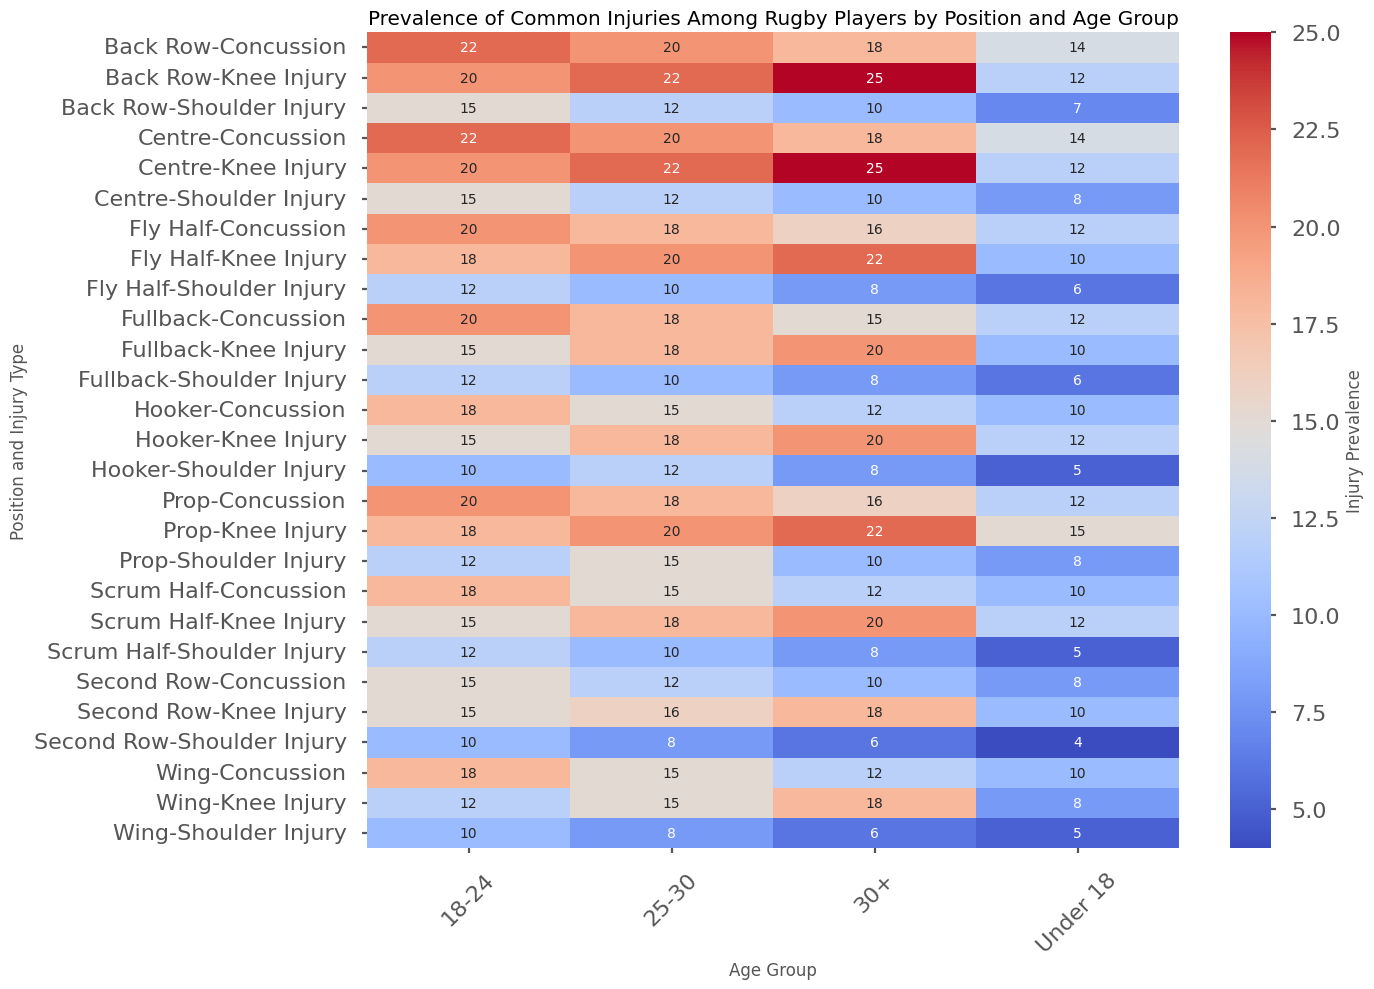What is the prevalence of knee injuries among Back Rows aged 30+? Look for the prevalence value of knee injuries for the Back Row position in the 30+ age group in the heatmap.
Answer: 25 Which age group has the highest prevalence of shoulder injuries among Fly Halfs? Compare the prevalence values of shoulder injuries for the Fly Half position across all age groups in the heatmap.
Answer: 18-24 How many total concussions are reported for Hookers across all age groups? Sum the prevalence values of concussions for the Hooker position across all age groups: 10 (Under 18) + 18 (18-24) + 15 (25-30) + 12 (30+).
Answer: 55 Is the prevalence of knee injuries higher among Scrum Halfs or Centres aged 25-30? Compare the prevalence values of knee injuries for Scrum Halfs and Centres in the 25-30 age group in the heatmap.
Answer: Centres What age group shows the highest prevalence of concussions for Props? Compare the prevalence values of concussions for Props across all age groups in the heatmap.
Answer: 18-24 What is the average prevalence of shoulder injuries across all positions for the Under 18 age group? Sum the prevalence values of shoulder injuries for the Under 18 age group across all positions (8 + 5 + 4 + 7 + 5 + 6 + 8 + 5 + 6) and divide by the number of positions (9).
Answer: 6.0 Between the age groups 25-30 and 30+, which one shows a lower prevalence of knee injuries among Second Rows? Compare the prevalence values of knee injuries for Second Rows in the 25-30 and 30+ age groups in the heatmap.
Answer: 25-30 What is the total number of shoulder injuries reported for the Wing position across all age groups? Sum the prevalence values of shoulder injuries for the Wing position across all age groups: 5 (Under 18) + 10 (18-24) + 8 (25-30) + 6 (30+).
Answer: 29 Which position and age group combination has the lowest prevalence of concussions? Find the lowest prevalence value for concussions in the entire heatmap and note its corresponding position and age group.
Answer: Second Row, Under 18 